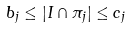<formula> <loc_0><loc_0><loc_500><loc_500>b _ { j } \leq | I \cap \pi _ { j } | \leq c _ { j }</formula> 